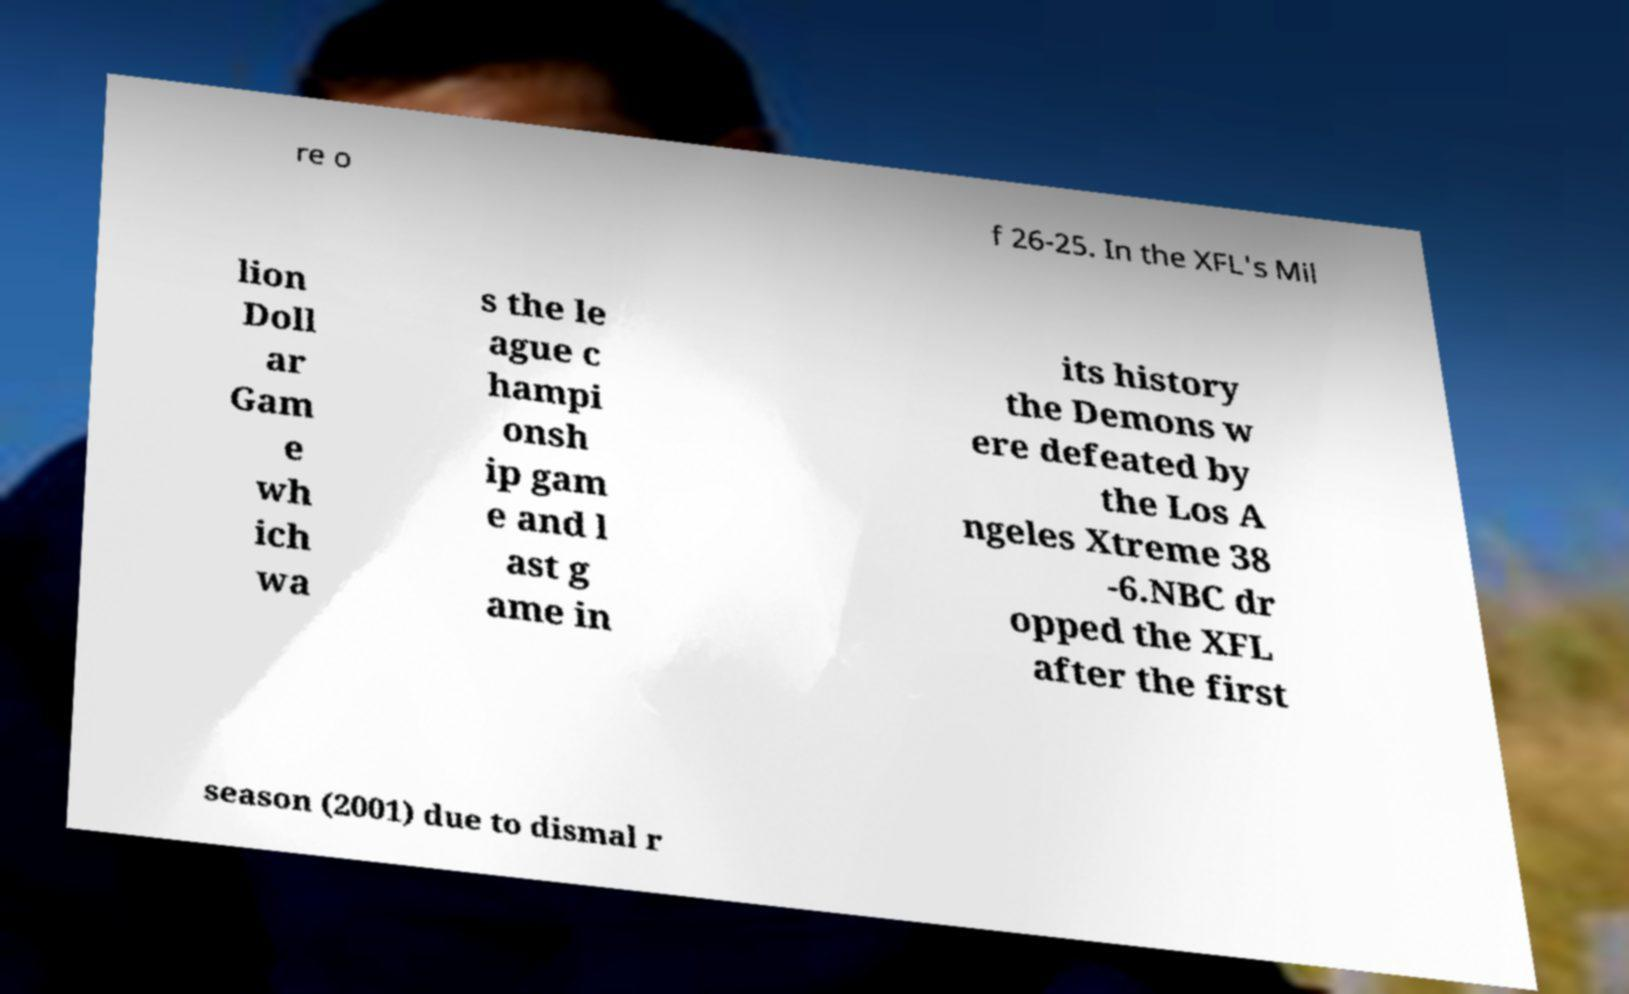Can you accurately transcribe the text from the provided image for me? re o f 26-25. In the XFL's Mil lion Doll ar Gam e wh ich wa s the le ague c hampi onsh ip gam e and l ast g ame in its history the Demons w ere defeated by the Los A ngeles Xtreme 38 -6.NBC dr opped the XFL after the first season (2001) due to dismal r 